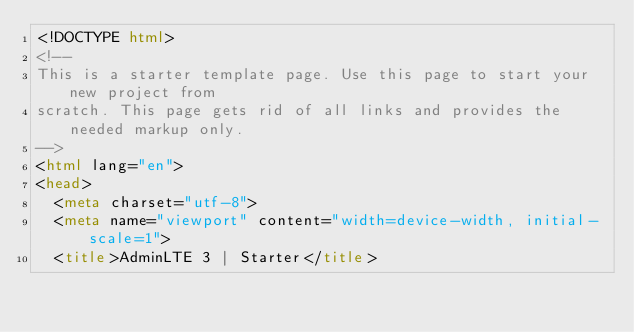<code> <loc_0><loc_0><loc_500><loc_500><_HTML_><!DOCTYPE html>
<!--
This is a starter template page. Use this page to start your new project from
scratch. This page gets rid of all links and provides the needed markup only.
-->
<html lang="en">
<head>
  <meta charset="utf-8">
  <meta name="viewport" content="width=device-width, initial-scale=1">
  <title>AdminLTE 3 | Starter</title>
</code> 